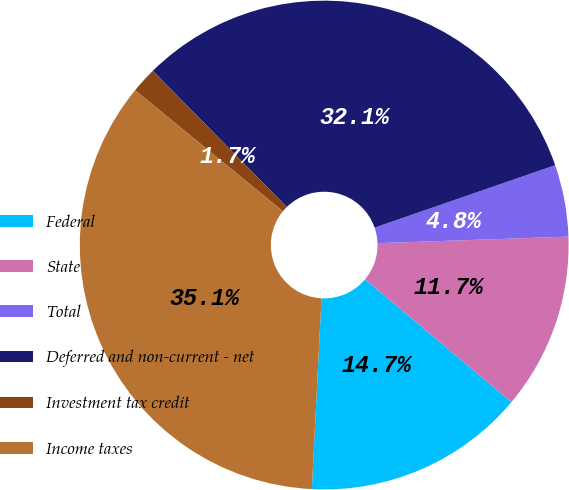Convert chart. <chart><loc_0><loc_0><loc_500><loc_500><pie_chart><fcel>Federal<fcel>State<fcel>Total<fcel>Deferred and non-current - net<fcel>Investment tax credit<fcel>Income taxes<nl><fcel>14.69%<fcel>11.66%<fcel>4.75%<fcel>32.07%<fcel>1.71%<fcel>35.11%<nl></chart> 